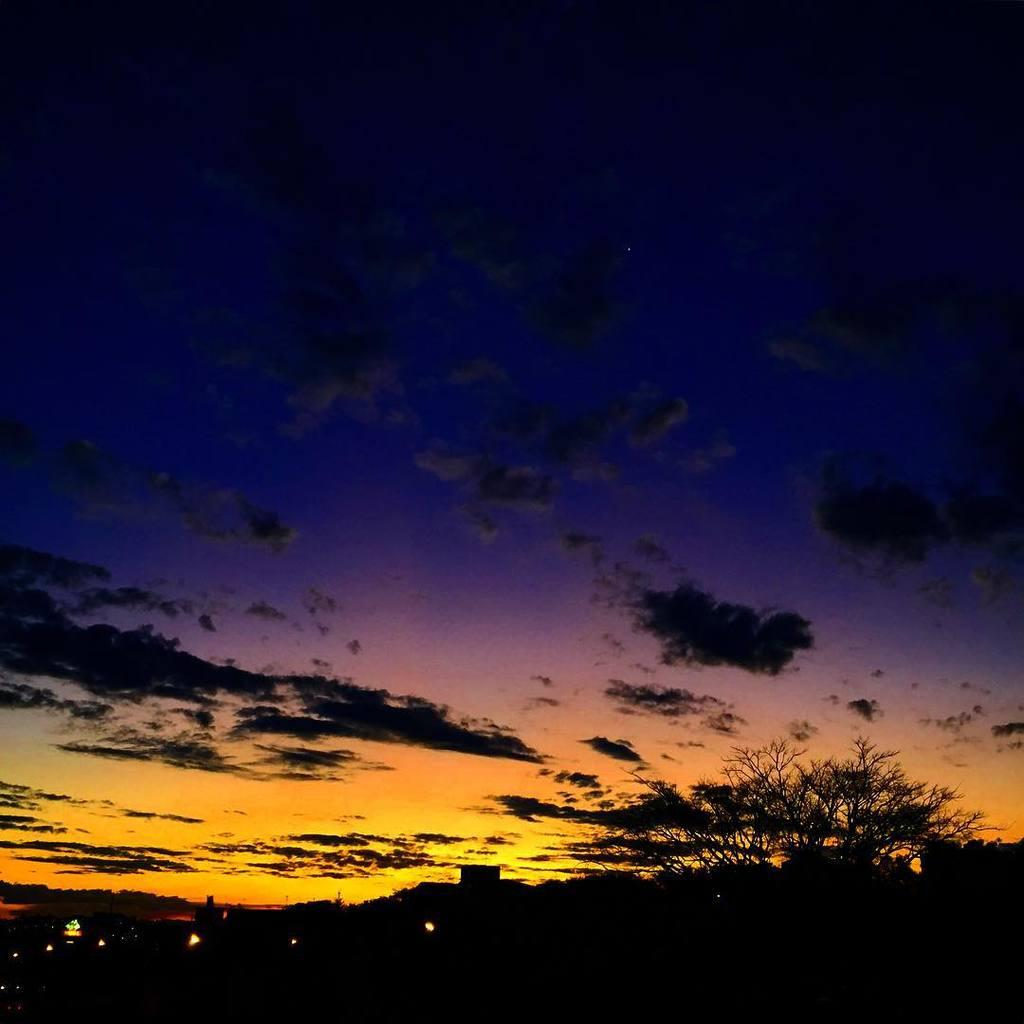What type of plant can be seen in the image? There is a tree in the image. What part of the natural environment is visible in the image? The sky is visible in the background of the image. What type of government is depicted in the image? There is no depiction of a government in the image; it features a tree and the sky. How many circles can be seen in the image? There are no circles present in the image. 